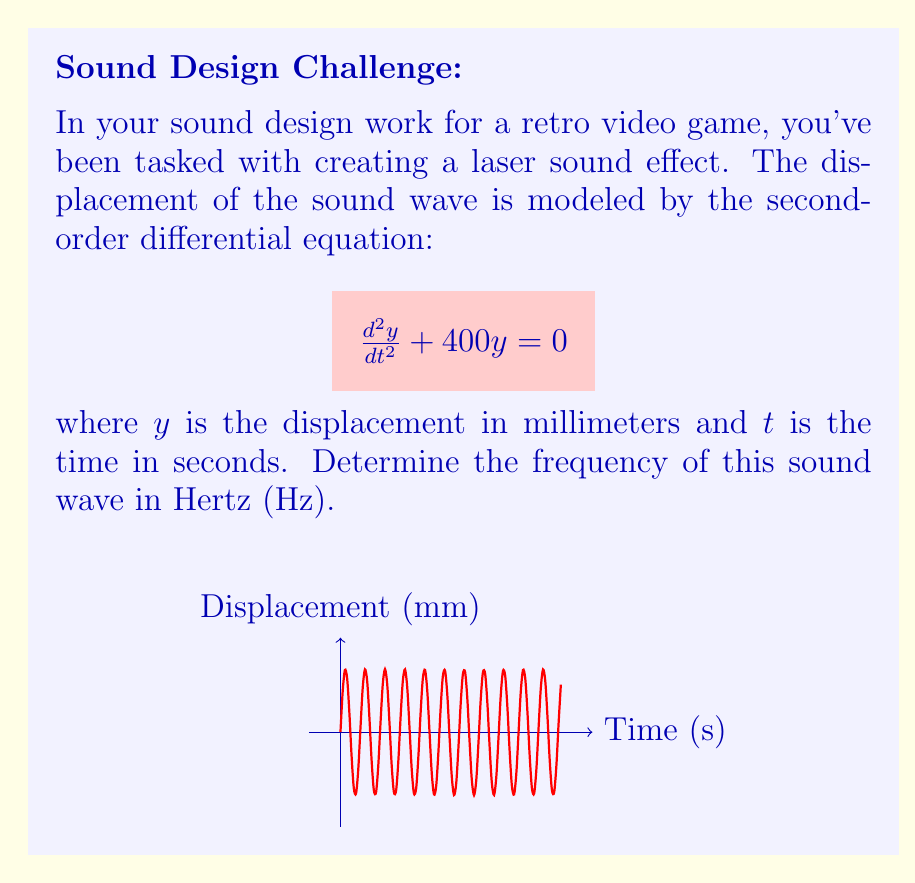What is the answer to this math problem? Let's approach this step-by-step:

1) The general form of a second-order linear differential equation for simple harmonic motion is:

   $$\frac{d^2y}{dt^2} + \omega^2y = 0$$

   where $\omega$ is the angular frequency in radians per second.

2) Comparing our equation to this general form, we can see that:

   $$\omega^2 = 400$$

3) Solving for $\omega$:

   $$\omega = \sqrt{400} = 20 \text{ rad/s}$$

4) The relationship between angular frequency $\omega$ and frequency $f$ in Hz is:

   $$\omega = 2\pi f$$

5) Substituting our value for $\omega$:

   $$20 = 2\pi f$$

6) Solving for $f$:

   $$f = \frac{20}{2\pi} \approx 3.18 \text{ Hz}$$

7) Rounding to two decimal places:

   $$f \approx 3.18 \text{ Hz}$$

This frequency is quite low for a laser sound, which typically has a higher pitch. In video game sound design, you might consider using this as a base frequency and adding harmonics or modulation to create a more complex, higher-pitched laser sound.
Answer: $3.18 \text{ Hz}$ 